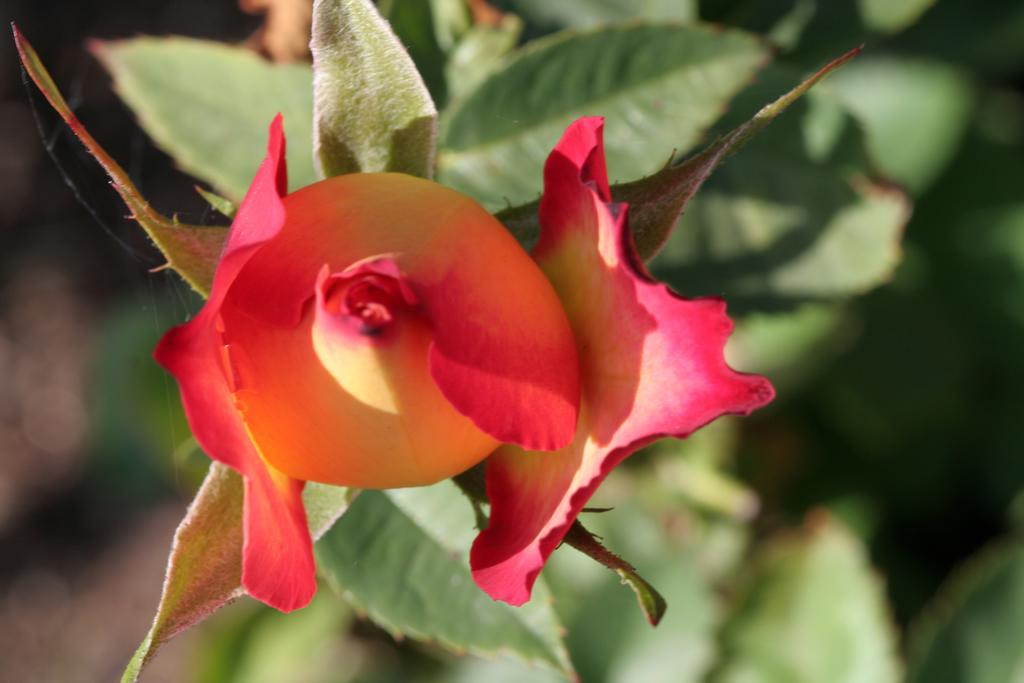What type of living organism can be seen in the image? There is a plant in the image. What specific part of the plant is visible in the image? There is a flower in the image. How does the plant help to balance the wheel in the image? There is no wheel present in the image, so the plant cannot help to balance it. 